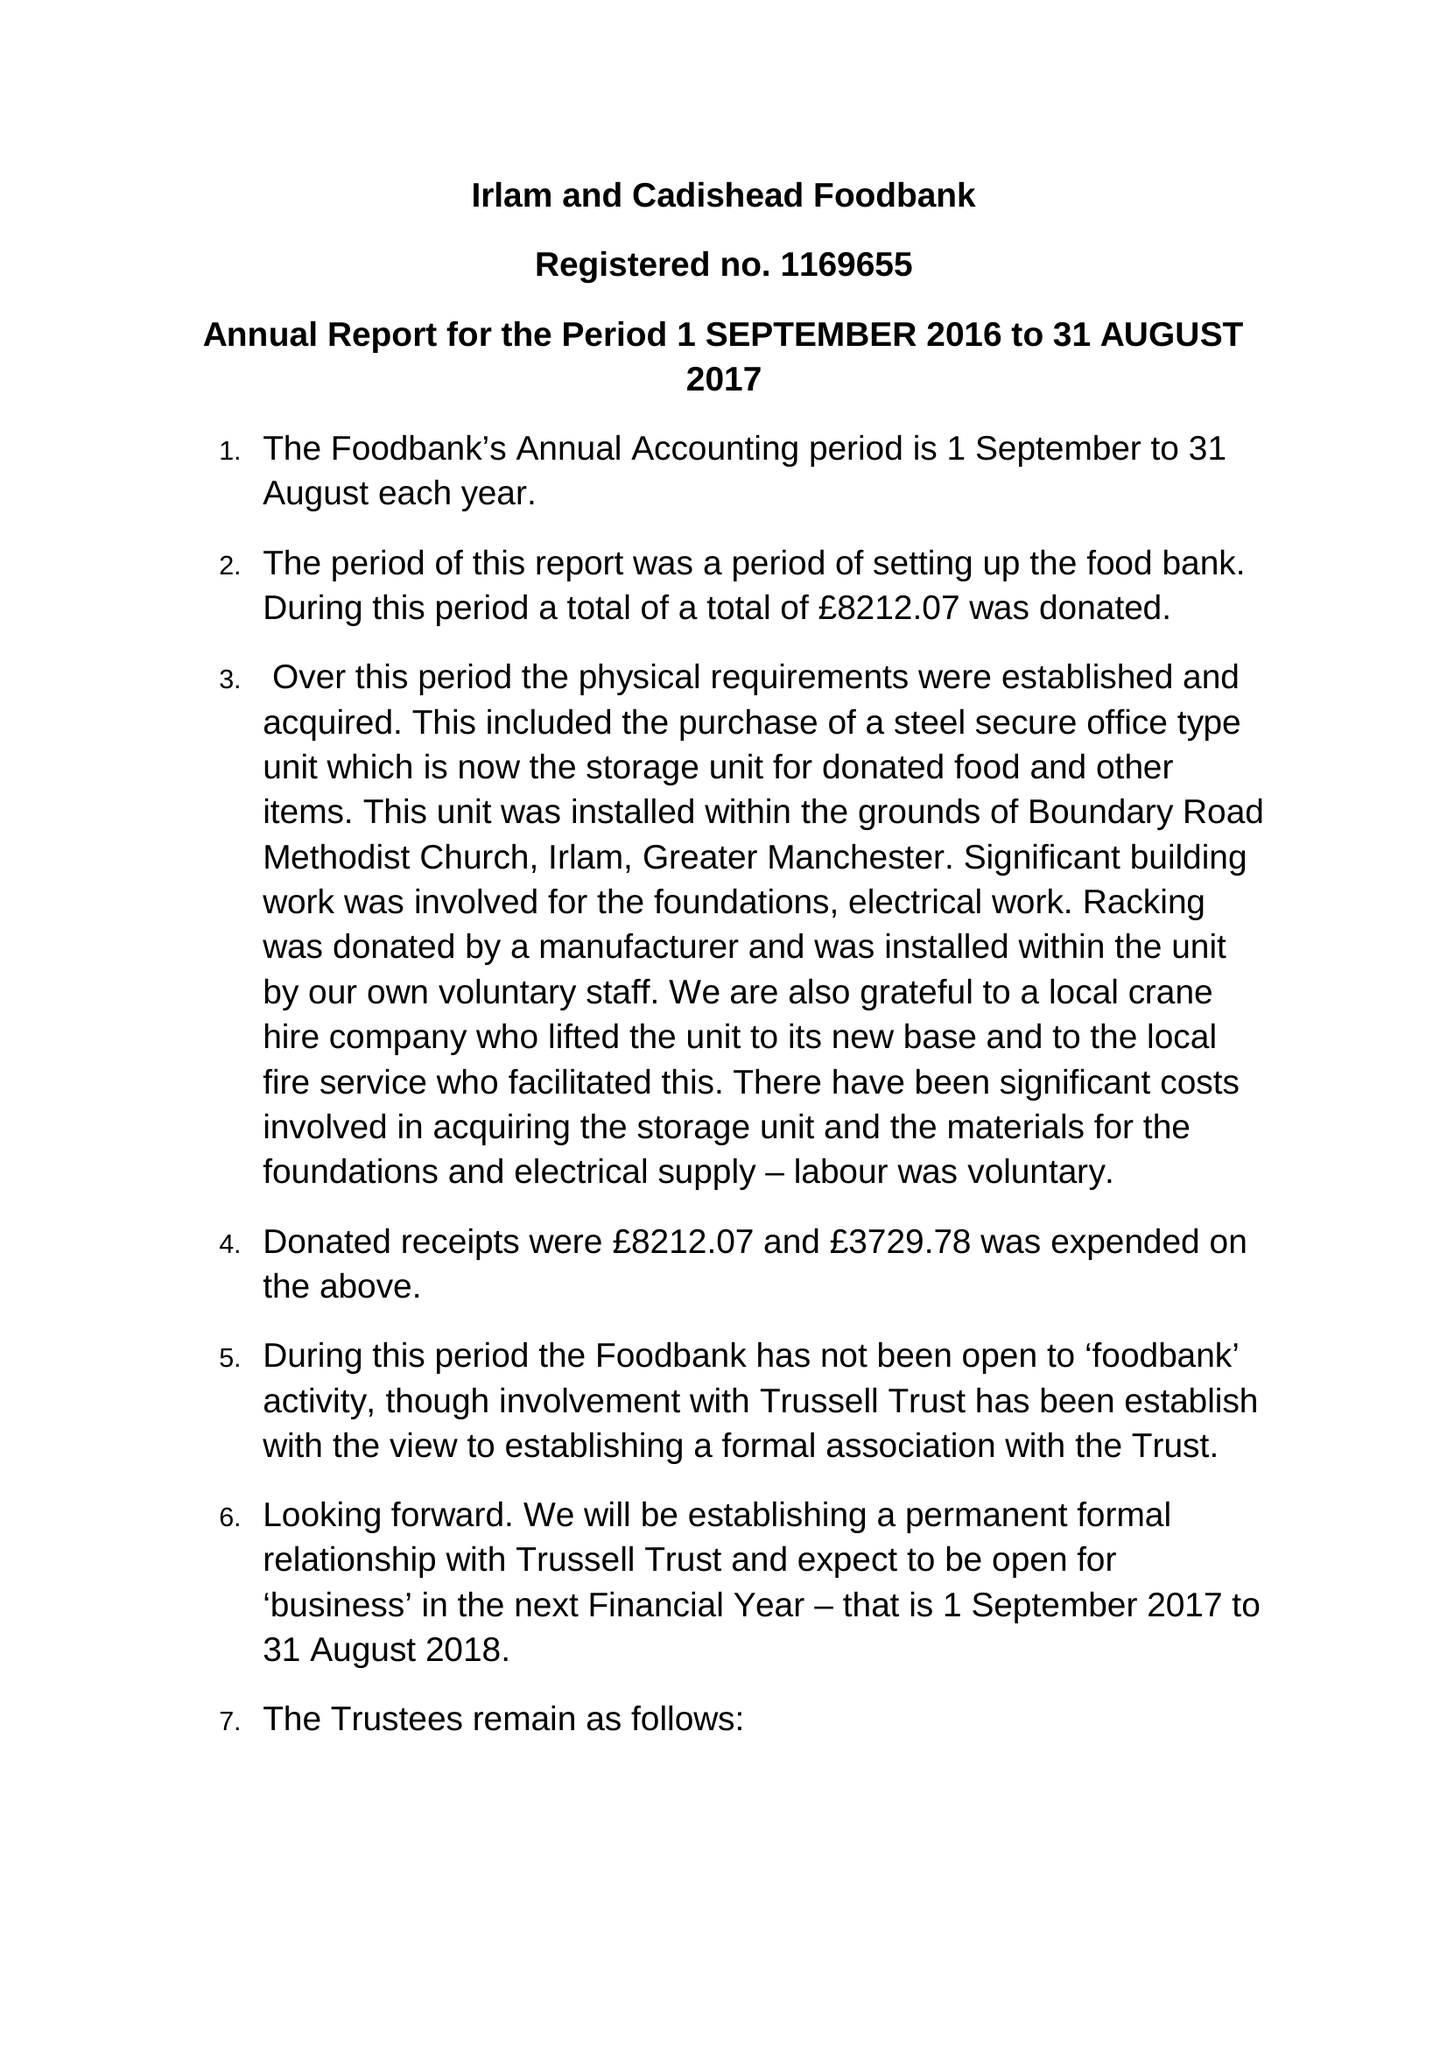What is the value for the charity_number?
Answer the question using a single word or phrase. 1169655 